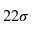Convert formula to latex. <formula><loc_0><loc_0><loc_500><loc_500>2 2 \sigma</formula> 